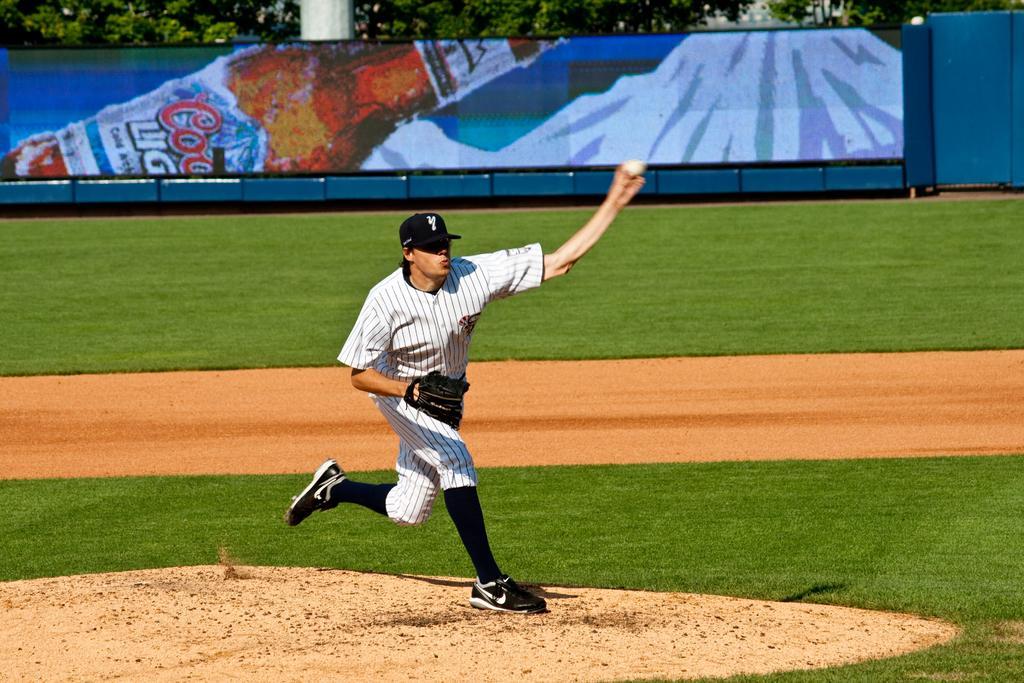In one or two sentences, can you explain what this image depicts? In this picture we can observe a baseball player, wearing a glove and holding a ball in his hand. He is wearing white color dress and he is wearing a cap which is in black color, on his head. He is in the baseball ground. In the background there is an advertisement of a drink. We can observe trees in the background. 